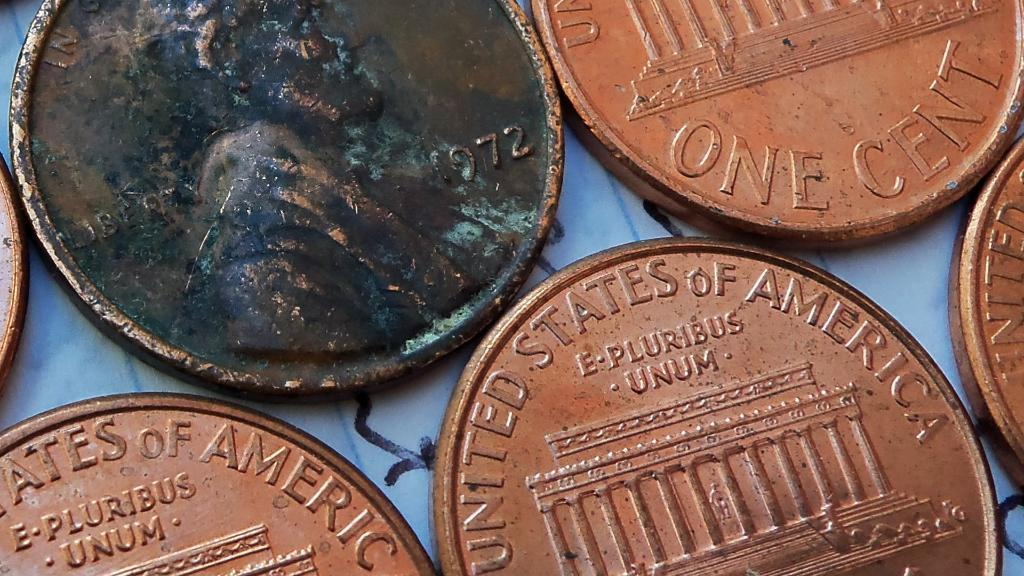What objects can be seen in the image? There are coins in the image. Can you describe the appearance of the coins? The coins appear to be round and have different designs or denominations. How many coins are visible in the image? The number of coins visible in the image cannot be determined from the provided facts. Are there any giants fighting in the image? No, there are no giants or fights depicted in the image; it only features coins. 